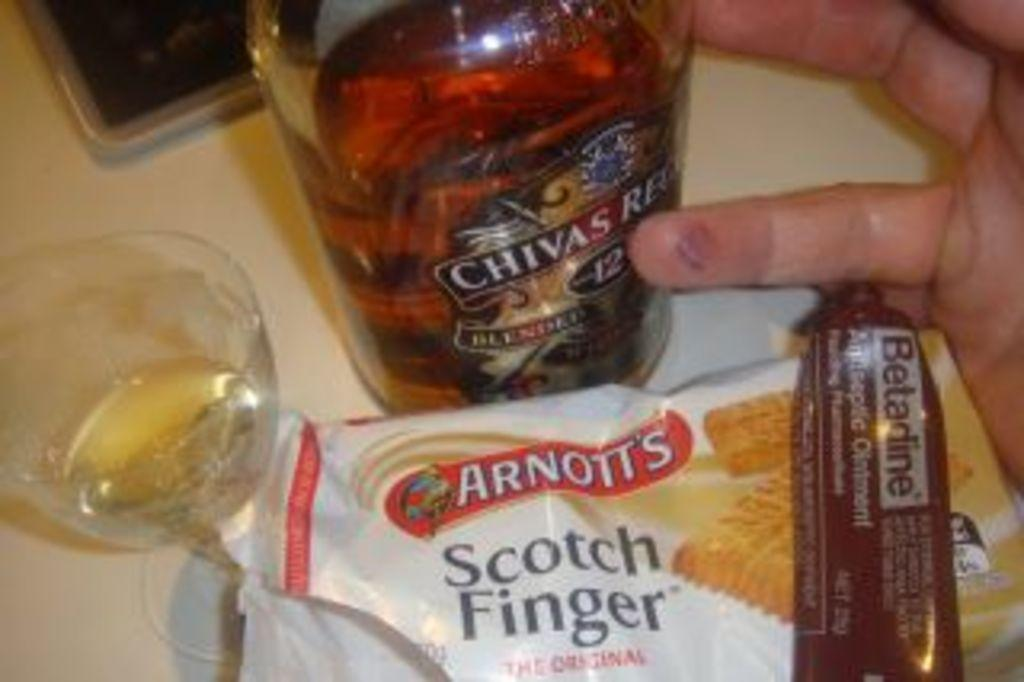<image>
Give a short and clear explanation of the subsequent image. A close up of someone's hand next to an assortment of snacks, a tumbler and a bottle of Chivas Regal 